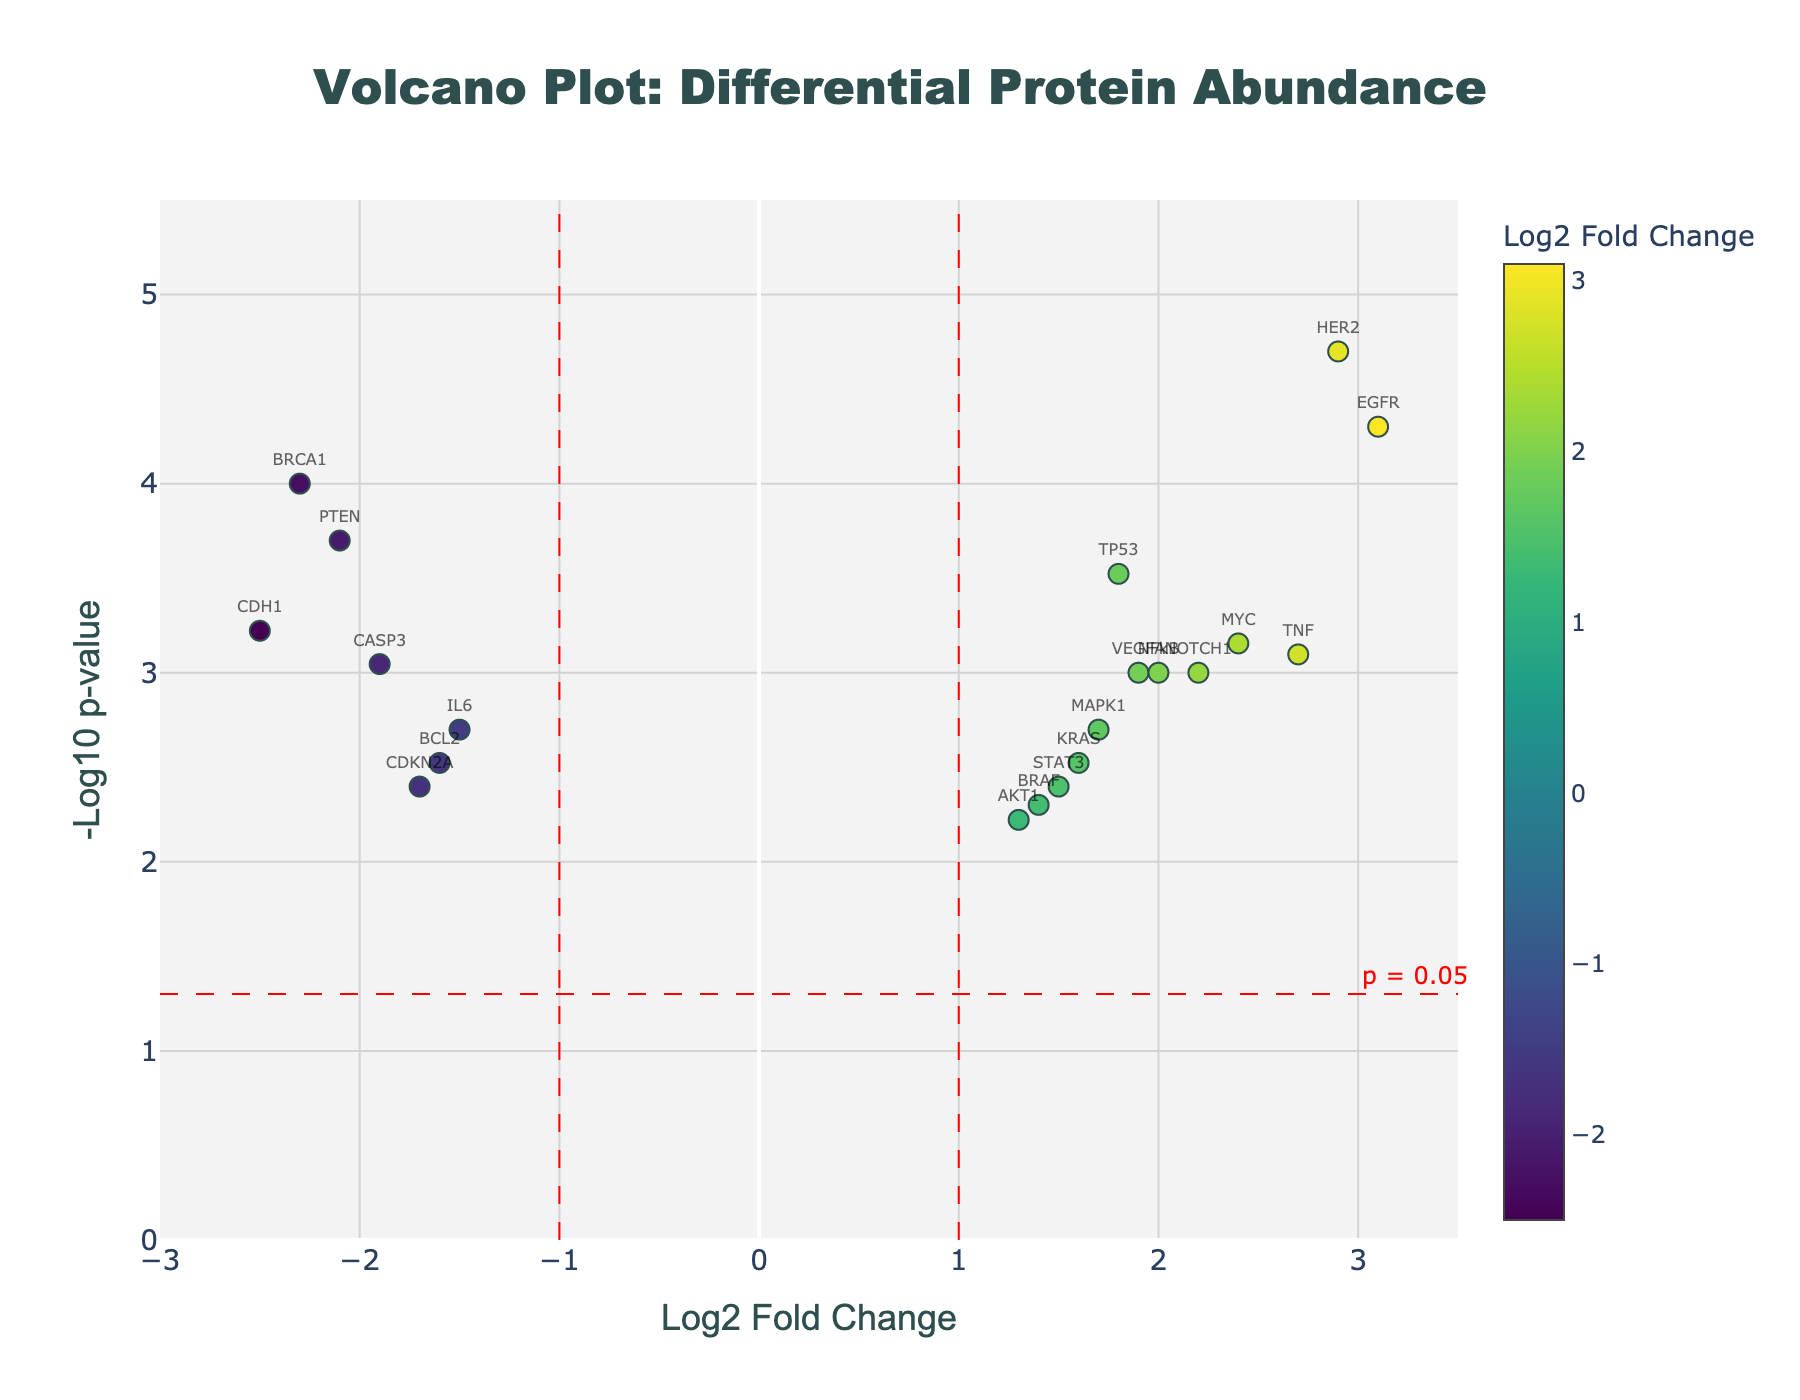What is the title of the figure? The title is often located at the top of the plot and helps to summarize the main focus or topic of the plot. In this case, it describes the subject being visualized.
Answer: "Volcano Plot: Differential Protein Abundance" How many proteins show a statistically significant change with a log2 fold change greater than 1? To determine this, look at the points located above the horizontal significance line (which indicates p = 0.05) and to the right of the vertical line at log2 fold change of 1. Count these points.
Answer: 5 Which protein has the highest log2 fold change in this plot? Identify the point that is farthest to the right on the x-axis. Check the corresponding label for this point.
Answer: EGFR What is the log2 fold change for the protein BRCA1, and is it upregulated or downregulated? Locate the point corresponding to BRCA1. Its position on the x-axis tells us the log2 fold change, and the sign (negative for left, positive for right) tells us if it is downregulated or upregulated.
Answer: -2.3, downregulated Which proteins have a log2 fold change between -2 and -1 and are statistically significant? Look for points within the range -2 < log2 fold change < -1 on the x-axis that also lie above the significance threshold on the y-axis. Identify the corresponding labels.
Answer: IL6, CDKN2A, BCL2 How many proteins have a p-value less than 0.001? To answer this, count the number of points that lie above -log10(p-value) = 3.
Answer: 9 What color are the points corresponding to downregulated proteins in this plot? Observing the color scale (showing the relationship between log2 fold change and color), note the colors that represent negative log2 fold changes.
Answer: Darker colors (likely greenish shades) Which protein exhibits the second highest -log10 p-value, and what is its log2 fold change? Identify the point with the second highest position on the y-axis and check its label and x-axis position.
Answer: TP53, 1.8 Is there a relationship between the intensity of the color of the points and the values of log2 fold changes? Look at the color scale alongside the plot. It indicates the correspondence between color intensity and log2 fold change values.
Answer: Yes, higher log2 fold change corresponds to more intense (brighter) colors What is the position of the significance threshold for p-value on the y-axis? Locate the horizontal dashed line (significance threshold line) and note its position on the y-axis, which represents -log10(0.05).
Answer: 1.301 